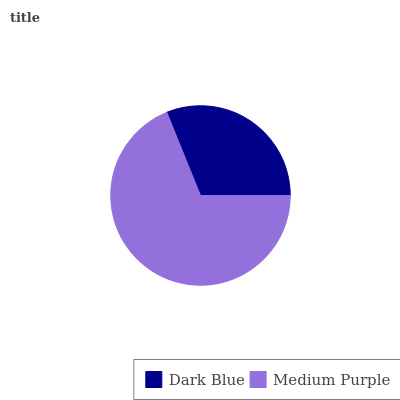Is Dark Blue the minimum?
Answer yes or no. Yes. Is Medium Purple the maximum?
Answer yes or no. Yes. Is Medium Purple the minimum?
Answer yes or no. No. Is Medium Purple greater than Dark Blue?
Answer yes or no. Yes. Is Dark Blue less than Medium Purple?
Answer yes or no. Yes. Is Dark Blue greater than Medium Purple?
Answer yes or no. No. Is Medium Purple less than Dark Blue?
Answer yes or no. No. Is Medium Purple the high median?
Answer yes or no. Yes. Is Dark Blue the low median?
Answer yes or no. Yes. Is Dark Blue the high median?
Answer yes or no. No. Is Medium Purple the low median?
Answer yes or no. No. 